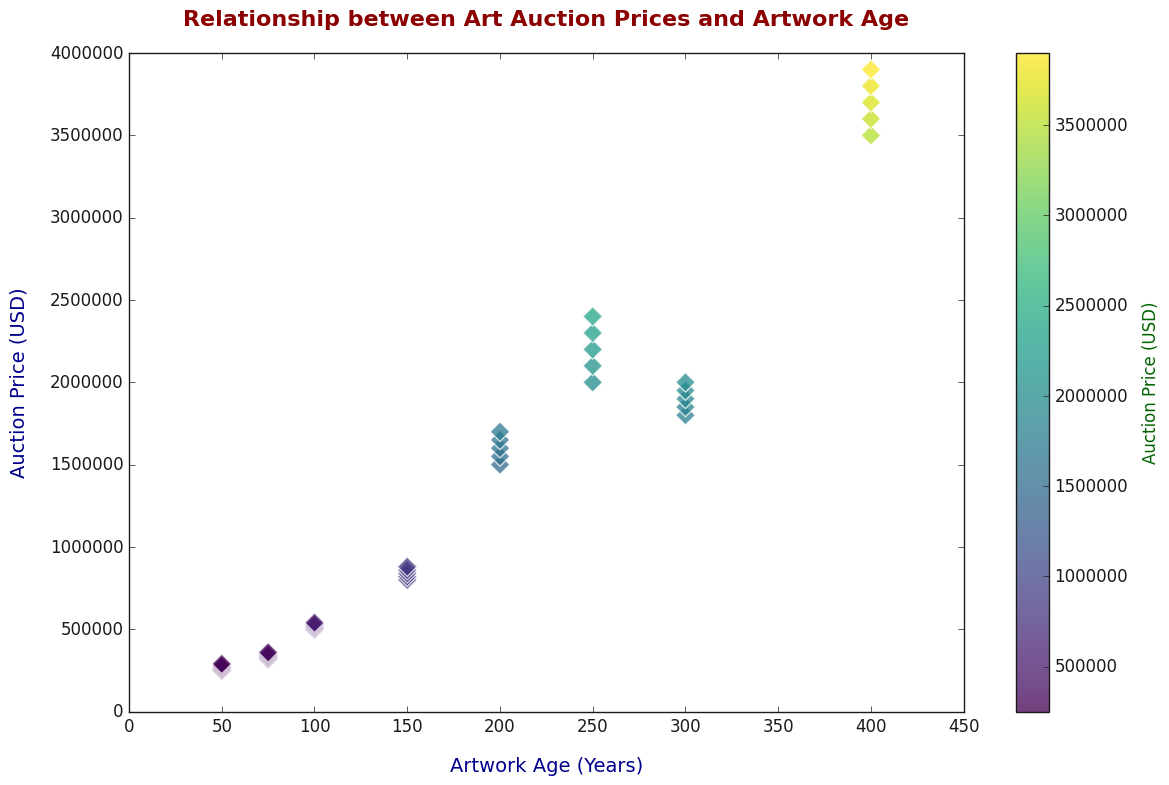What's the oldest artwork in the dataset, and what was its auction price? The scatter plot's x-axis represents the artwork age, with the oldest artwork located at the far right. The corresponding auction price can be found on the y-axis. The oldest artwork in the dataset is 400 years old, and its auction price is around 3,900,000 USD.
Answer: 400 years, 3,900,000 USD What is the range of auction prices for artworks that are 100 years old? Locate the points on the scatter plot corresponding to 100 years on the x-axis. The auction prices for 100-year-old artworks range from approximately 500,000 USD to 540,000 USD.
Answer: 500,000 USD to 540,000 USD Which age group of artworks has the highest auction prices? Refer to the auction prices on the y-axis and identify which age group (x-axis) shows the highest points. The artworks aged 400 years have the highest auction prices, reaching up to 3,900,000 USD.
Answer: 400 years Is there an increasing trend in auction prices as the artwork age increases? Observe the general direction of the scatter points as you move from left to right on the scatter plot. Yes, there is an increasing trend in auction prices as the artwork age increases.
Answer: Yes What is the auction price difference between the oldest and youngest artworks? Identify the highest auction price of the 400-year-old artwork and the price of the 50-year-old artwork. The difference is 3,900,000 USD - 250,000 USD = 3,650,000 USD.
Answer: 3,650,000 USD Which age group shows the highest variation in auction prices? For each age group, compare the spread of auction prices. The age group of 50 years shows a wide range of auction prices from 250,000 USD to 290,000 USD, indicating high variation.
Answer: 50 years What is the average auction price for artworks aged 300 years? Identify the auction prices for artworks at 300 years and calculate their average: (1800000 + 1850000 + 1900000 + 1950000 + 2000000) / 5 = 1,900,000 USD.
Answer: 1,900,000 USD 